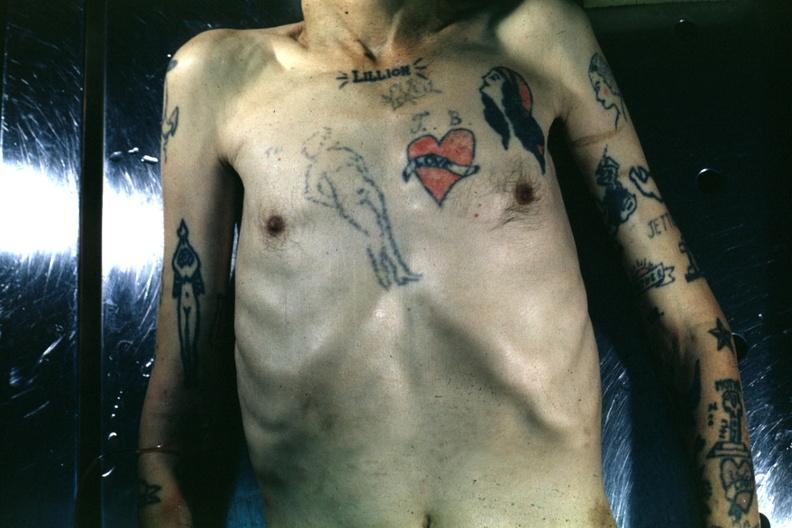how does this image show upper portion of body?
Answer the question using a single word or phrase. With many tattoos 